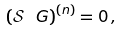Convert formula to latex. <formula><loc_0><loc_0><loc_500><loc_500>\left ( \mathcal { S } \ G \right ) ^ { ( n ) } & = 0 \, ,</formula> 